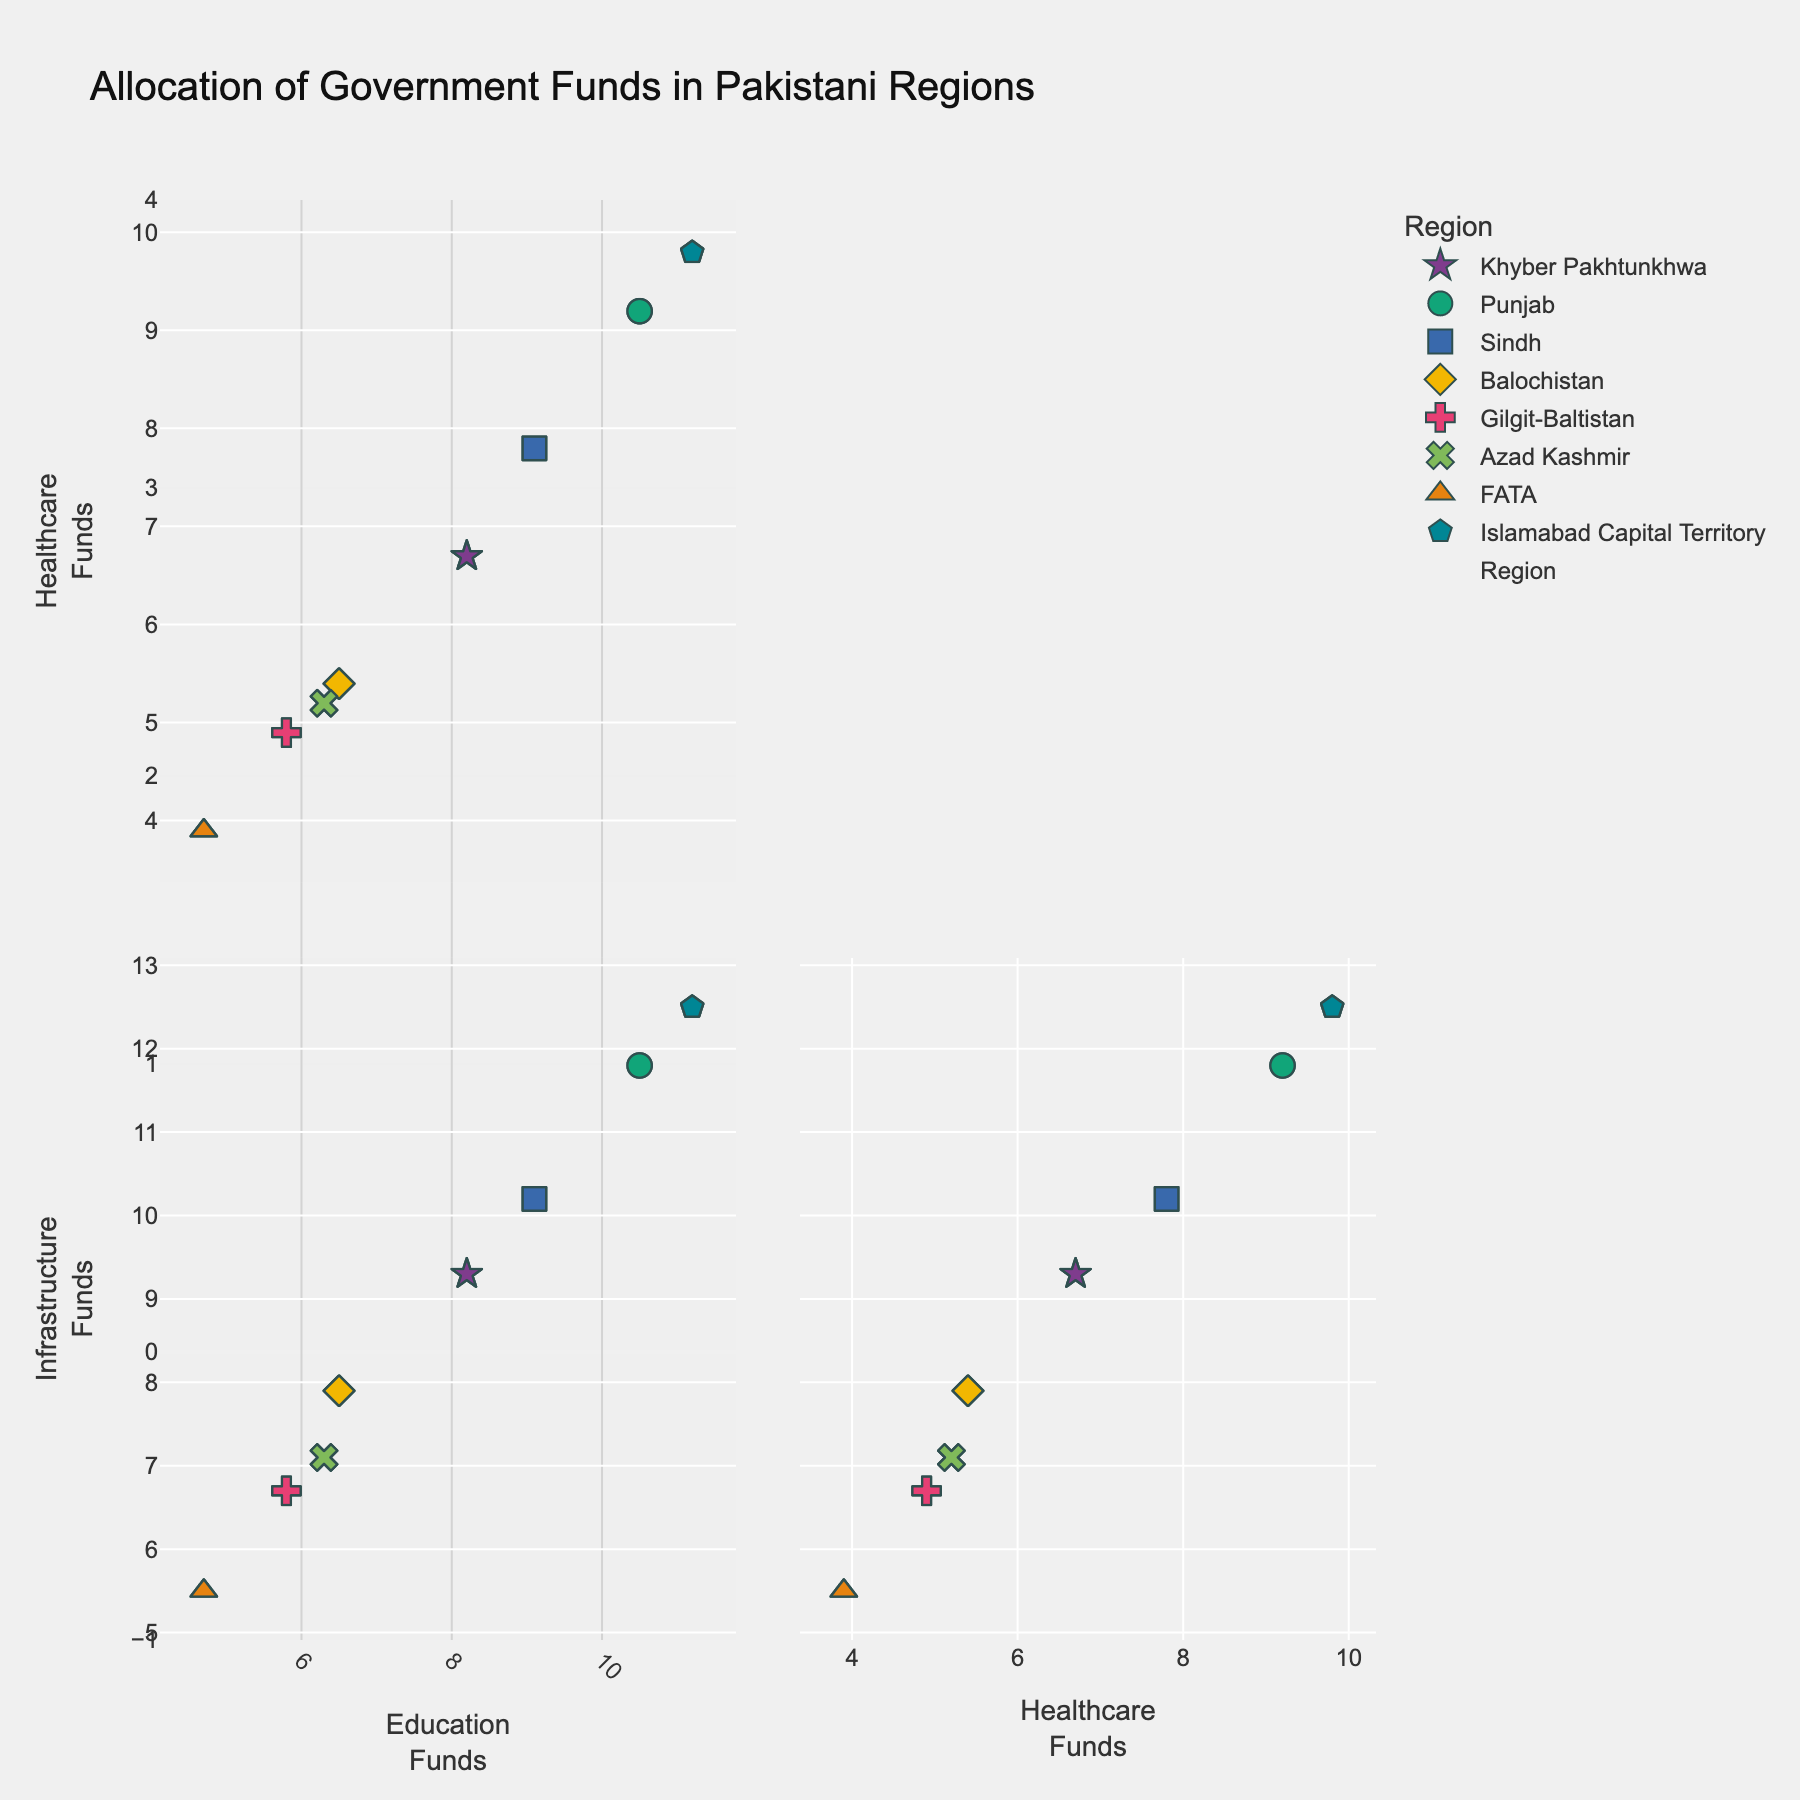What are the colors representing different regions in the plot? Each region is represented by a different color in the plot. For instance, Punjab might be in one specific color, Sindh in another, and so on. You can visually identify different regions by looking at their respective colors in the legend.
Answer: Various distinct colors What is the title of the scatterplot matrix? The title is displayed at the top of the plot. It typically summarizes what the plot is about.
Answer: Allocation of Government Funds in Pakistani Regions Which region has the highest allocation for education funds? By looking at the scatterplot matrix, you can identify the region whose data points are furthest to the right on the Education Funds axis.
Answer: Islamabad Capital Territory Is there any region with higher funds in healthcare than in education? Observe the data points on the plots comparing Healthcare Funds against Education Funds. If any data point lies above the diagonal line where Healthcare Funds equal Education Funds, then that region has higher healthcare funds.
Answer: No Between Punjab and Sindh, which region receives more funds for infrastructure? Compare the positions of the data points for Punjab and Sindh along the Infrastructure Funds axis. The higher value on the axis indicates more funding.
Answer: Punjab Which region receives the least amount of funds for all three purposes (education, healthcare, infrastructure)? Find the data point that appears lower on all three axes across the different scatterplots.
Answer: FATA How does the allocation of funds for education compare between Khyber Pakhtunkhwa and Balochistan? Compare the data points representing Khyber Pakhtunkhwa and Balochistan on the Education Funds axis.
Answer: Higher in Khyber Pakhtunkhwa What is the relationship between healthcare funds and infrastructure funds across regions? Look for a pattern or trend in the scatterplot comparing Healthcare Funds and Infrastructure Funds. Positive or negative correlations may be identified.
Answer: Positive correlation Which region's allocation of healthcare funds almost matches that of education funds? Look for data points that lie close to the diagonal line in the scatterplot comparing Healthcare Funds and Education Funds.
Answer: Punjab How does the Islamabad Capital Territory's allocation of healthcare funds compare to other regions? Compare the data point for Islamabad Capital Territory on the Healthcare Funds axis with those of other regions.
Answer: Highest 